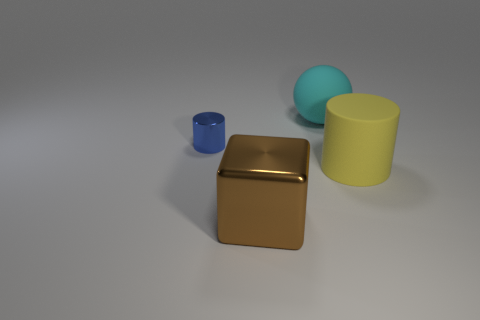What is the size of the cylinder that is made of the same material as the cube?
Ensure brevity in your answer.  Small. The object that is both to the left of the big yellow rubber thing and to the right of the brown object is made of what material?
Your response must be concise. Rubber. There is a cylinder that is the same size as the brown object; what color is it?
Provide a short and direct response. Yellow. What is the material of the big thing behind the object that is to the left of the large brown block?
Make the answer very short. Rubber. What number of big things are behind the brown thing and in front of the small blue cylinder?
Keep it short and to the point. 1. How many other things are there of the same size as the blue cylinder?
Keep it short and to the point. 0. Do the metal thing that is behind the big brown shiny object and the big yellow rubber thing that is behind the large brown cube have the same shape?
Offer a terse response. Yes. Are there any big cyan things on the left side of the large yellow object?
Make the answer very short. Yes. What is the color of the tiny metallic thing that is the same shape as the large yellow object?
Offer a terse response. Blue. Is there any other thing that is the same shape as the cyan rubber thing?
Your answer should be very brief. No. 